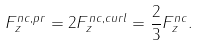<formula> <loc_0><loc_0><loc_500><loc_500>F _ { z } ^ { n c , p r } = 2 F _ { z } ^ { n c , c u r l } = \frac { 2 } { 3 } F _ { z } ^ { n c } .</formula> 